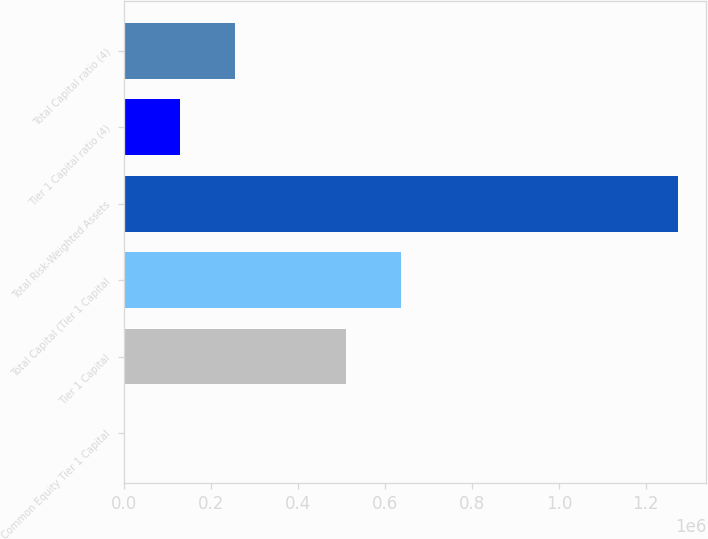Convert chart. <chart><loc_0><loc_0><loc_500><loc_500><bar_chart><fcel>Common Equity Tier 1 Capital<fcel>Tier 1 Capital<fcel>Total Capital (Tier 1 Capital<fcel>Total Risk-Weighted Assets<fcel>Tier 1 Capital ratio (4)<fcel>Total Capital ratio (4)<nl><fcel>13.07<fcel>509877<fcel>637343<fcel>1.27467e+06<fcel>127479<fcel>254945<nl></chart> 